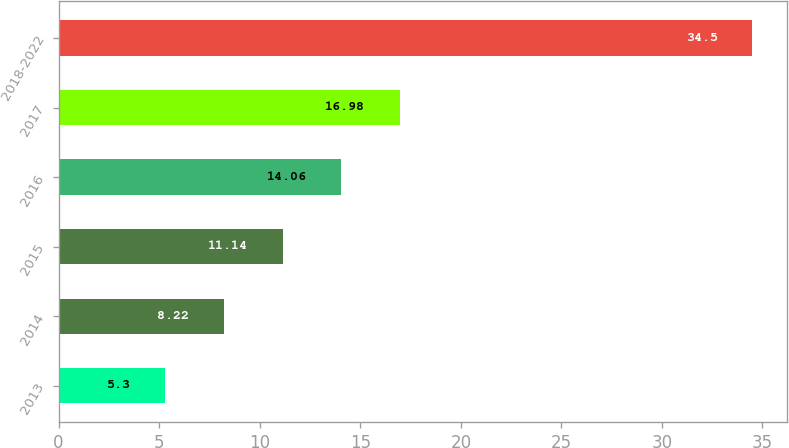Convert chart to OTSL. <chart><loc_0><loc_0><loc_500><loc_500><bar_chart><fcel>2013<fcel>2014<fcel>2015<fcel>2016<fcel>2017<fcel>2018-2022<nl><fcel>5.3<fcel>8.22<fcel>11.14<fcel>14.06<fcel>16.98<fcel>34.5<nl></chart> 